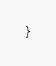Convert code to text. <code><loc_0><loc_0><loc_500><loc_500><_CSS_>}
</code> 